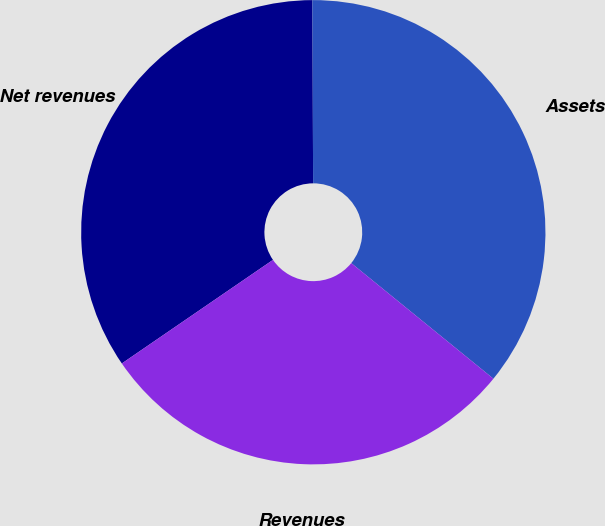Convert chart. <chart><loc_0><loc_0><loc_500><loc_500><pie_chart><fcel>Net revenues<fcel>Assets<fcel>Revenues<nl><fcel>34.5%<fcel>35.93%<fcel>29.57%<nl></chart> 